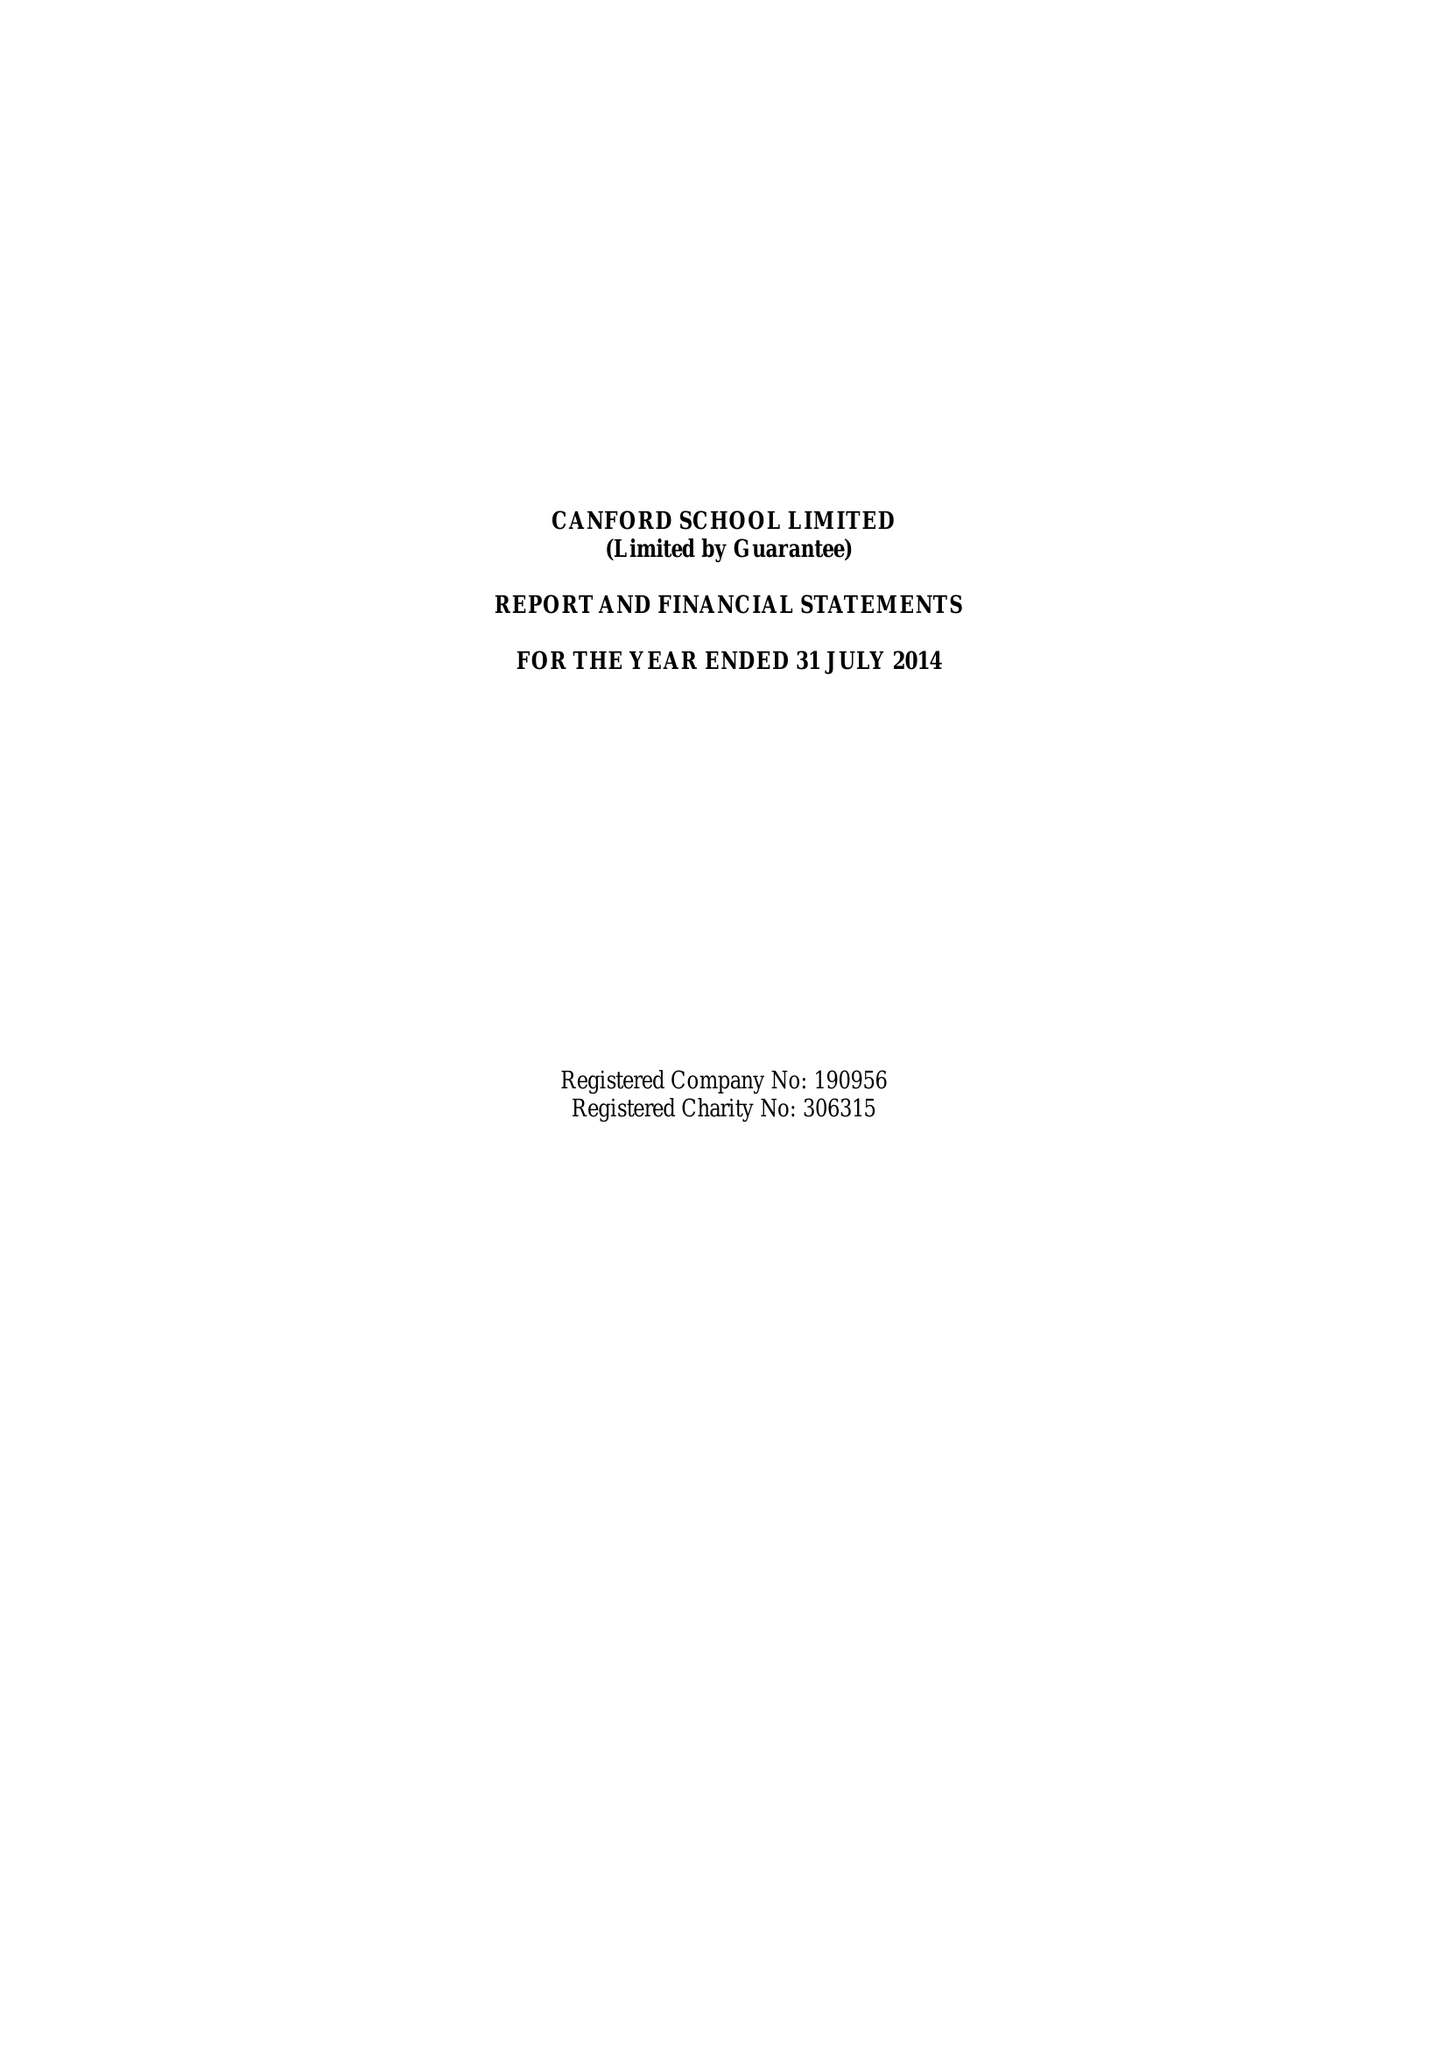What is the value for the report_date?
Answer the question using a single word or phrase. 2014-07-31 